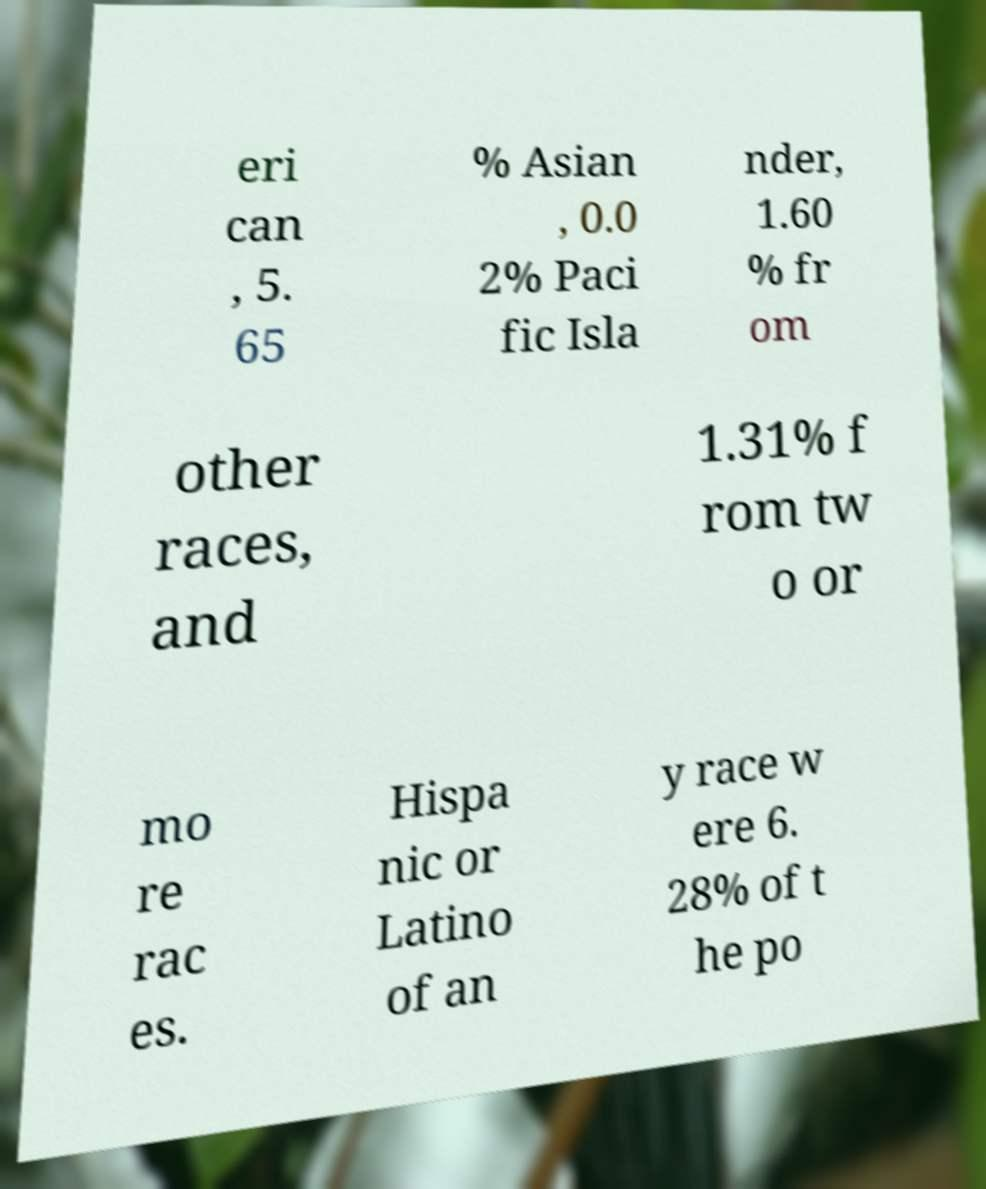Please identify and transcribe the text found in this image. eri can , 5. 65 % Asian , 0.0 2% Paci fic Isla nder, 1.60 % fr om other races, and 1.31% f rom tw o or mo re rac es. Hispa nic or Latino of an y race w ere 6. 28% of t he po 